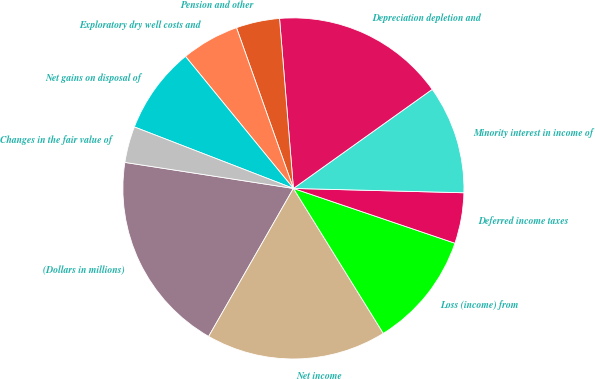Convert chart to OTSL. <chart><loc_0><loc_0><loc_500><loc_500><pie_chart><fcel>(Dollars in millions)<fcel>Net income<fcel>Loss (income) from<fcel>Deferred income taxes<fcel>Minority interest in income of<fcel>Depreciation depletion and<fcel>Pension and other<fcel>Exploratory dry well costs and<fcel>Net gains on disposal of<fcel>Changes in the fair value of<nl><fcel>19.16%<fcel>17.11%<fcel>10.96%<fcel>4.8%<fcel>10.27%<fcel>16.43%<fcel>4.12%<fcel>5.49%<fcel>8.22%<fcel>3.43%<nl></chart> 